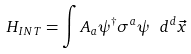<formula> <loc_0><loc_0><loc_500><loc_500>H _ { I N T } = \int A _ { a } \psi ^ { \dagger } \sigma ^ { a } \psi \ d ^ { d } \vec { x }</formula> 